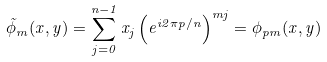Convert formula to latex. <formula><loc_0><loc_0><loc_500><loc_500>\tilde { \phi } _ { m } ( x , y ) = \sum _ { j = 0 } ^ { n - 1 } x _ { j } \left ( e ^ { i 2 \pi p / n } \right ) ^ { m j } = \phi _ { p m } ( x , y )</formula> 